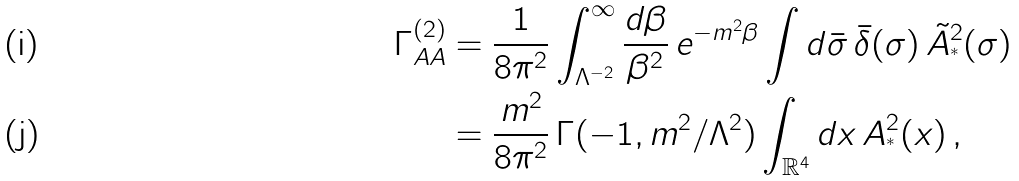Convert formula to latex. <formula><loc_0><loc_0><loc_500><loc_500>\Gamma ^ { ( 2 ) } _ { A A } & = \frac { 1 } { 8 \pi ^ { 2 } } \int _ { \Lambda ^ { - 2 } } ^ { \infty } \frac { d \beta } { \beta ^ { 2 } } \, e ^ { - m ^ { 2 } \beta } \int d \bar { \sigma } \, \bar { \delta } ( \sigma ) \, \tilde { A } ^ { 2 } _ { ^ { * } } ( \sigma ) \\ & = \frac { m ^ { 2 } } { 8 \pi ^ { 2 } } \, \Gamma ( - 1 , m ^ { 2 } / \Lambda ^ { 2 } ) \int _ { \mathbb { R } ^ { 4 } } d x \, A _ { ^ { * } } ^ { 2 } ( x ) \, ,</formula> 